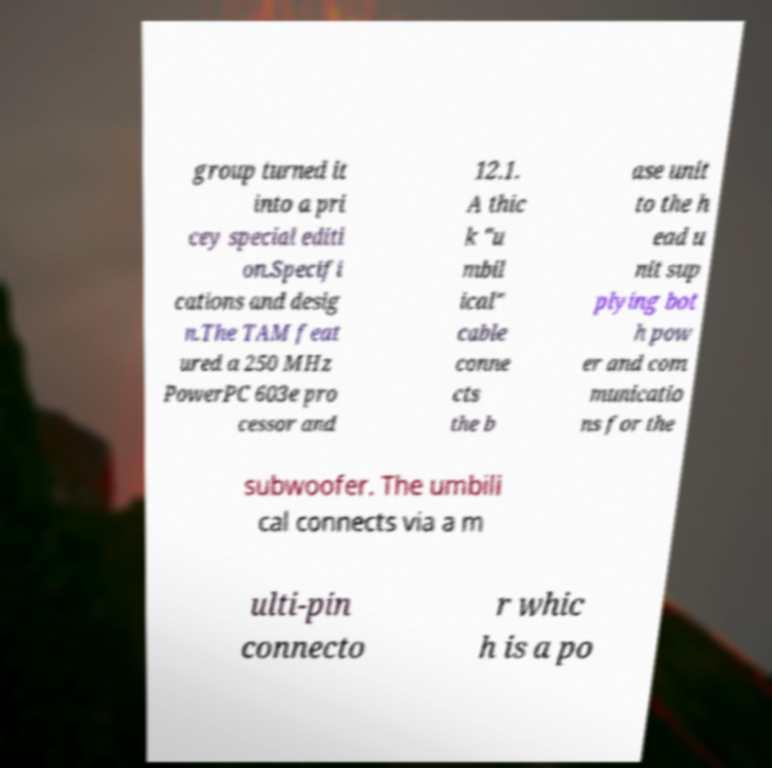Could you assist in decoding the text presented in this image and type it out clearly? group turned it into a pri cey special editi on.Specifi cations and desig n.The TAM feat ured a 250 MHz PowerPC 603e pro cessor and 12.1. A thic k "u mbil ical" cable conne cts the b ase unit to the h ead u nit sup plying bot h pow er and com municatio ns for the subwoofer. The umbili cal connects via a m ulti-pin connecto r whic h is a po 